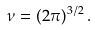Convert formula to latex. <formula><loc_0><loc_0><loc_500><loc_500>\nu = ( 2 \pi ) ^ { 3 / 2 } \, .</formula> 